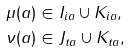Convert formula to latex. <formula><loc_0><loc_0><loc_500><loc_500>\mu ( a ) & \in I _ { i a } \cup K _ { i a } , \\ \nu ( a ) & \in J _ { t a } \cup K _ { t a } ,</formula> 